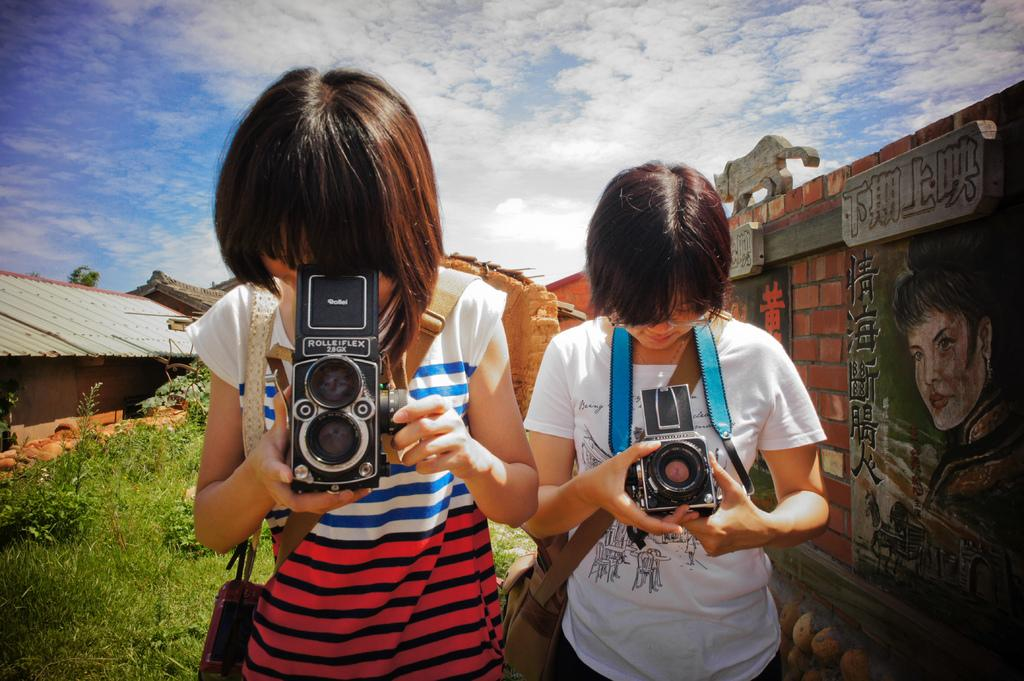How many people are present in the image? There are two people in the image. What are the people holding in their hands? The people are holding cameras in their hands. What is the condition of the sky in the image? The sky is clear in the image. What type of ground is visible in the image? The ground is filled with grass. What type of meal is being prepared on the beam in the image? There is no beam or meal present in the image. 